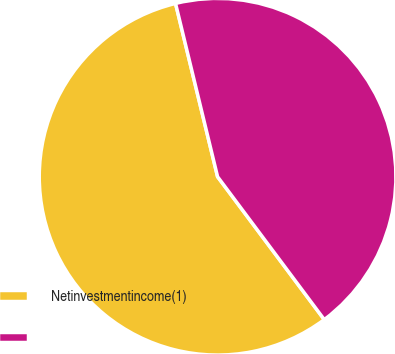Convert chart to OTSL. <chart><loc_0><loc_0><loc_500><loc_500><pie_chart><fcel>Netinvestmentincome(1)<fcel>Unnamed: 1<nl><fcel>56.42%<fcel>43.58%<nl></chart> 